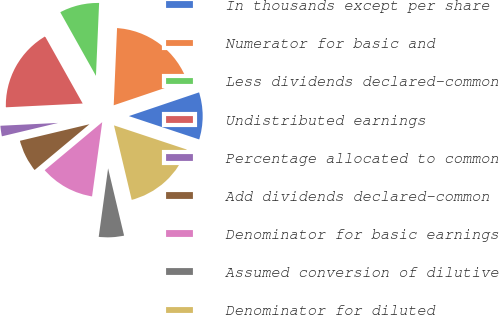Convert chart to OTSL. <chart><loc_0><loc_0><loc_500><loc_500><pie_chart><fcel>In thousands except per share<fcel>Numerator for basic and<fcel>Less dividends declared-common<fcel>Undistributed earnings<fcel>Percentage allocated to common<fcel>Add dividends declared-common<fcel>Denominator for basic earnings<fcel>Assumed conversion of dilutive<fcel>Denominator for diluted<nl><fcel>10.29%<fcel>19.12%<fcel>8.82%<fcel>17.65%<fcel>2.94%<fcel>7.35%<fcel>11.76%<fcel>5.88%<fcel>16.18%<nl></chart> 